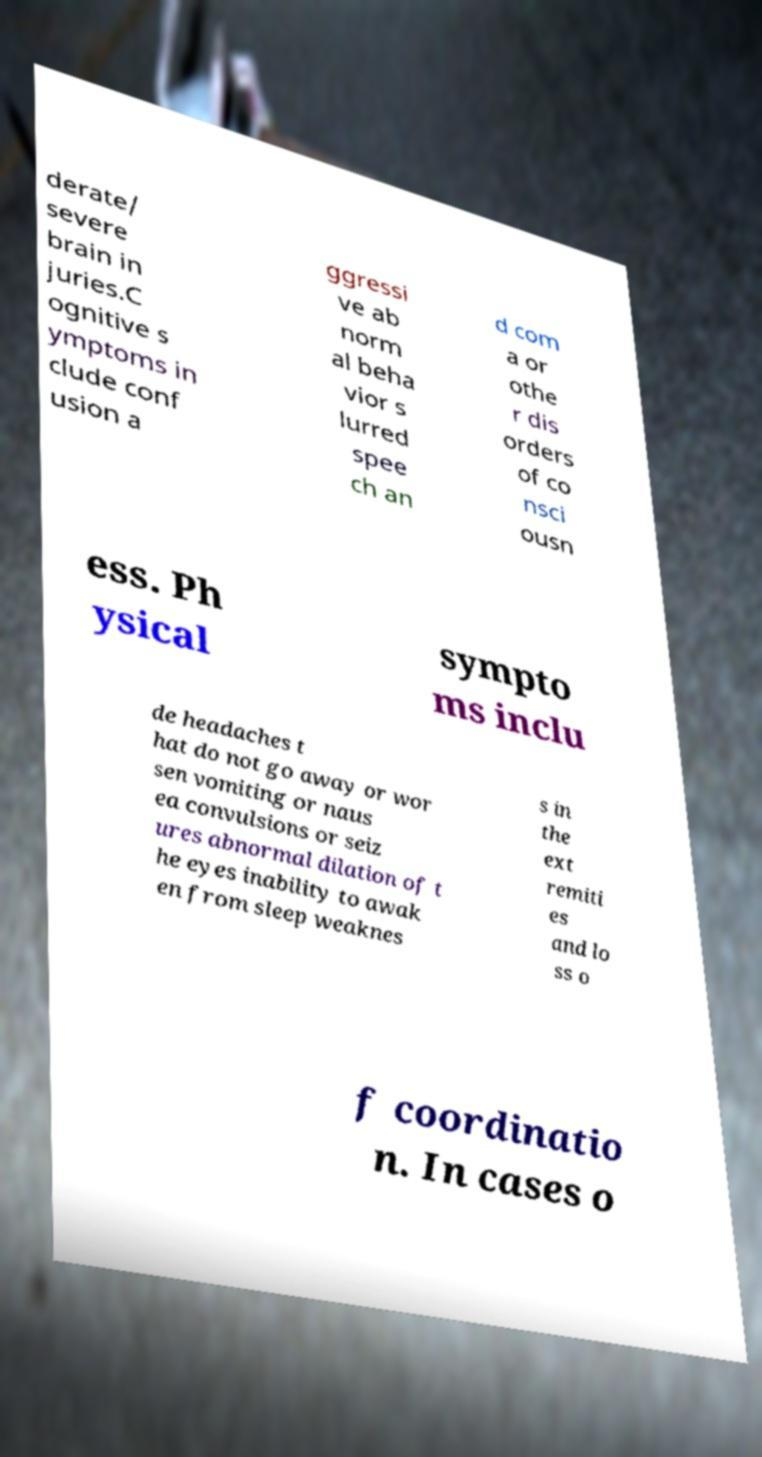What messages or text are displayed in this image? I need them in a readable, typed format. derate/ severe brain in juries.C ognitive s ymptoms in clude conf usion a ggressi ve ab norm al beha vior s lurred spee ch an d com a or othe r dis orders of co nsci ousn ess. Ph ysical sympto ms inclu de headaches t hat do not go away or wor sen vomiting or naus ea convulsions or seiz ures abnormal dilation of t he eyes inability to awak en from sleep weaknes s in the ext remiti es and lo ss o f coordinatio n. In cases o 